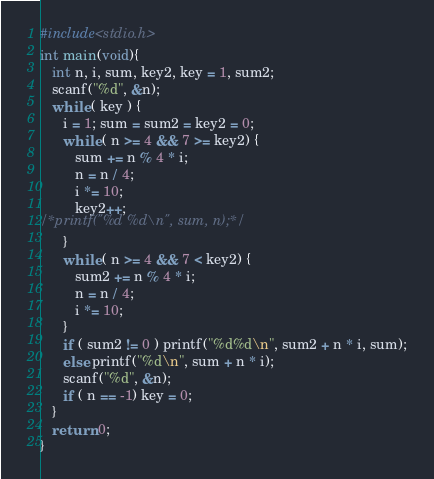<code> <loc_0><loc_0><loc_500><loc_500><_C_>#include<stdio.h>
int main(void){
   int n, i, sum, key2, key = 1, sum2;
   scanf("%d", &n);
   while ( key ) {
      i = 1; sum = sum2 = key2 = 0;
      while ( n >= 4 && 7 >= key2) {
         sum += n % 4 * i;
         n = n / 4;
         i *= 10;
         key2++;
/*printf("%d %d\n", sum, n);*/
      }
      while ( n >= 4 && 7 < key2) {
         sum2 += n % 4 * i;
         n = n / 4;
         i *= 10;
      }
      if ( sum2 != 0 ) printf("%d%d\n", sum2 + n * i, sum);
      else printf("%d\n", sum + n * i);
      scanf("%d", &n);
      if ( n == -1) key = 0;
   }
   return 0;
}</code> 